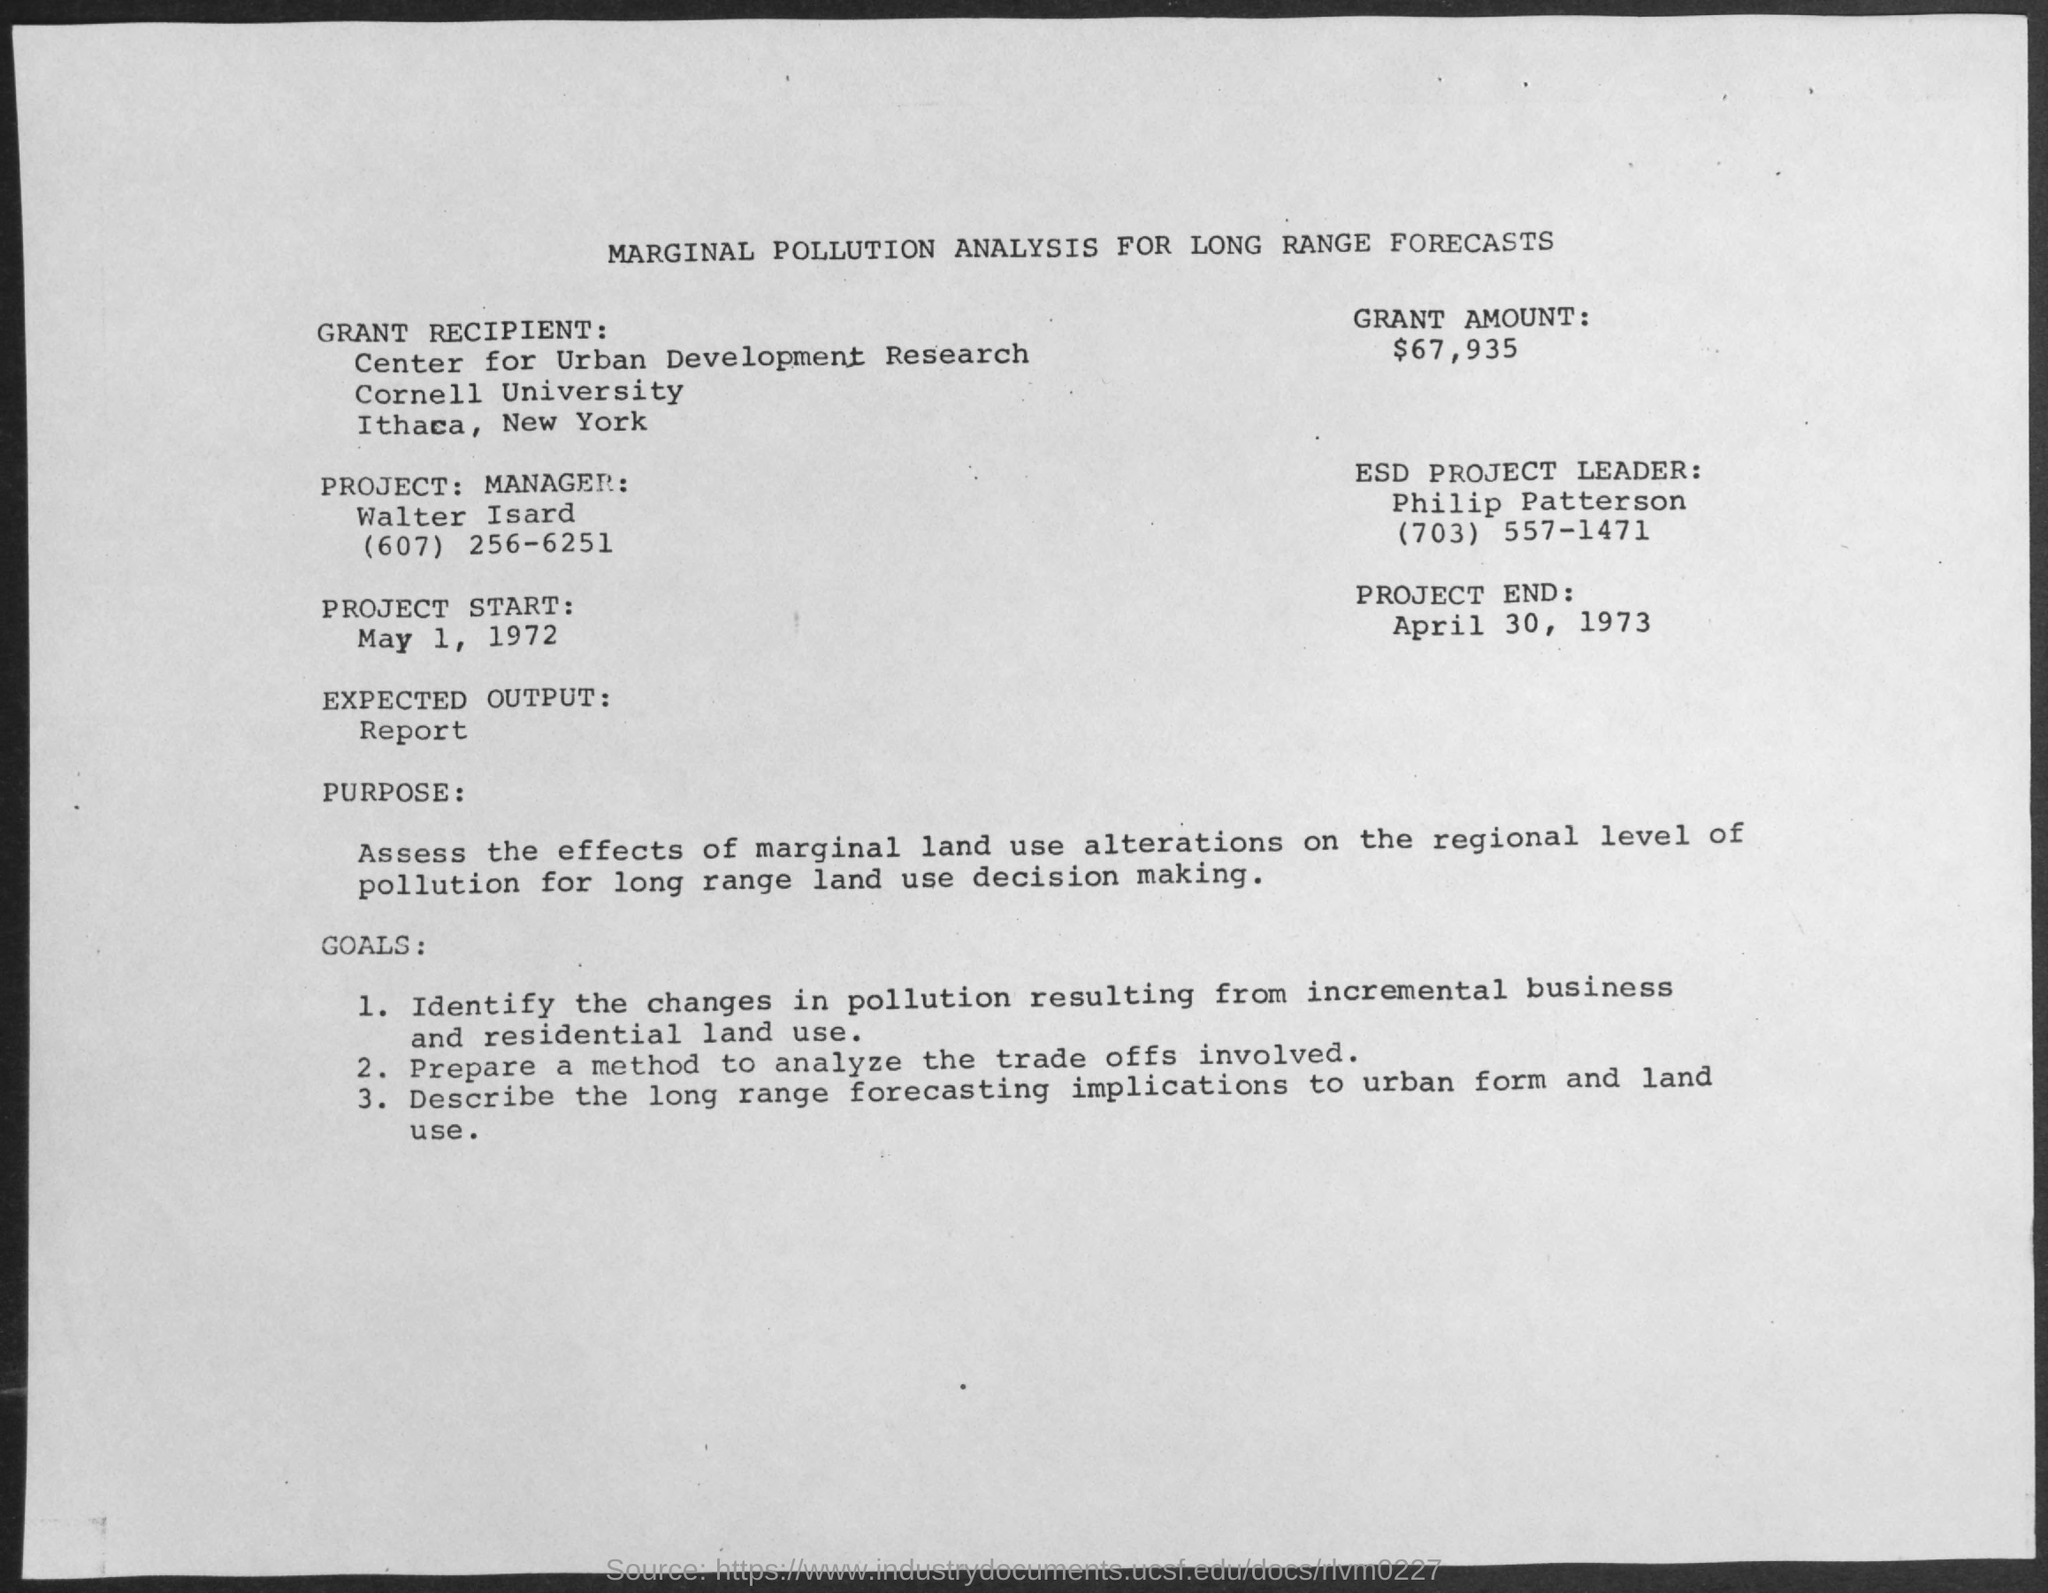Give some essential details in this illustration. The start date of the project is May 1, 1972. The expected output for the given analysis is described in the analysis report. The date for the completion of the project is April 30, 1973. The project manager is Walter Isard. The grant amount is $67,935. 